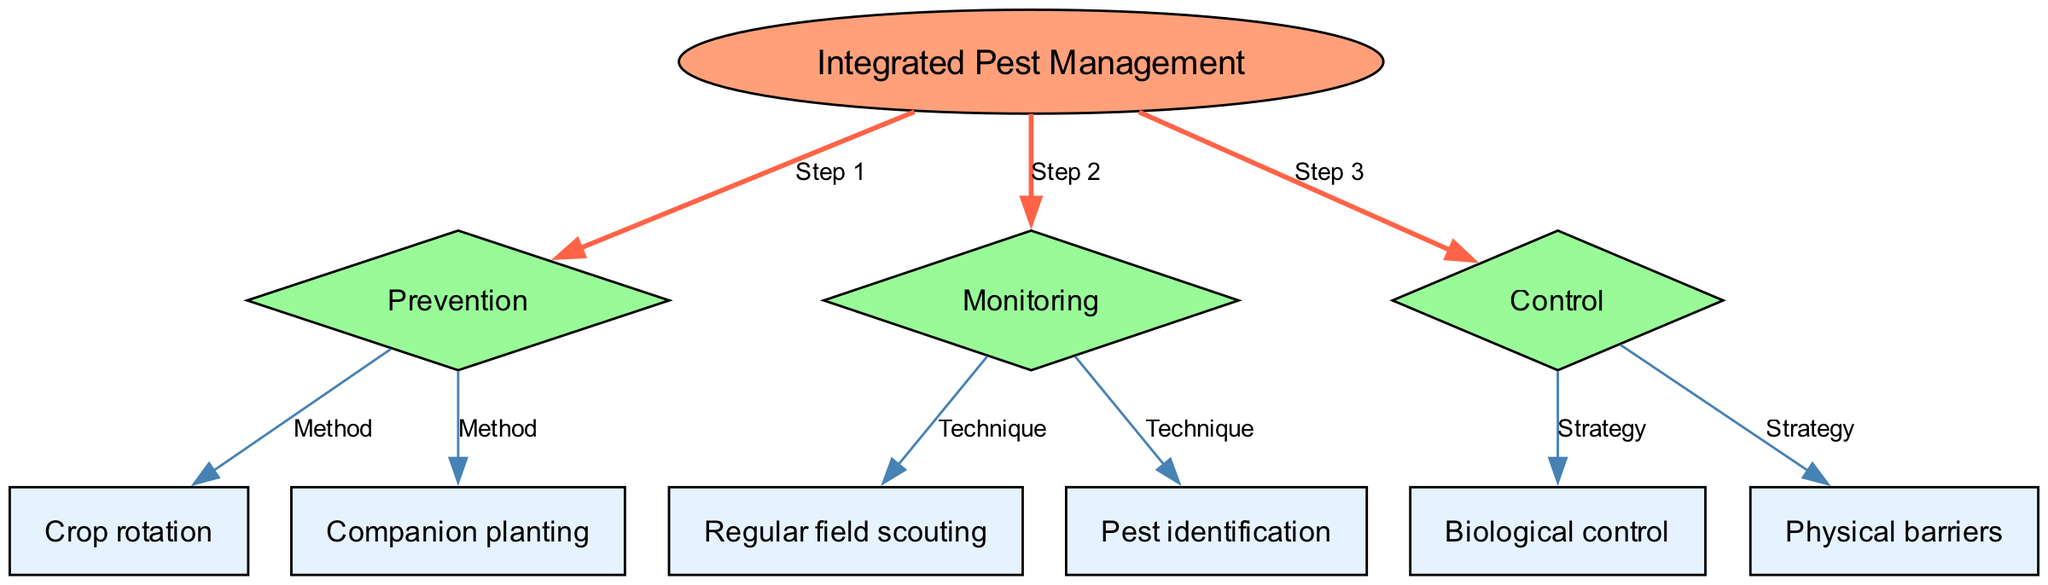What is the main topic of the diagram? The diagram's central node, labeled "Integrated Pest Management," indicates that this is the main topic being addressed.
Answer: Integrated Pest Management How many nodes are present in the diagram? The diagram contains a total of 10 nodes, each representing different aspects of integrated pest management strategies.
Answer: 10 What method is associated with the prevention step? The prevention step connects with "Crop rotation" and "Companion planting," which are both listed as methods for preventing pest issues.
Answer: Crop rotation What is the second step of the integrated pest management process? The second step is indicated by the edge leading from the main topic to the node labeled "Monitoring."
Answer: Monitoring What technique is used for pest identification? The diagram specifies that "Pest identification" is a technique under the monitoring step in integrated pest management.
Answer: Pest identification Which strategies are listed under the control step? The control step leads to "Biological control" and "Physical barriers," indicating these methods are used for pest control.
Answer: Biological control, Physical barriers How many edges connect to the "Monitoring" node? The "Monitoring" node has two edges leading to it, one connecting to "Regular field scouting" and the other to "Pest identification."
Answer: 2 What type of node is "Control"? The "Control" node is a diamond-shaped node, which indicates it represents a decision or process step in integrated pest management.
Answer: Diamond Which edge has a pen width of 2? The edge leading from the main node "Integrated Pest Management" to the "Prevention" node has a thicker pen width of 2, marking it as a significant connection.
Answer: Prevention 